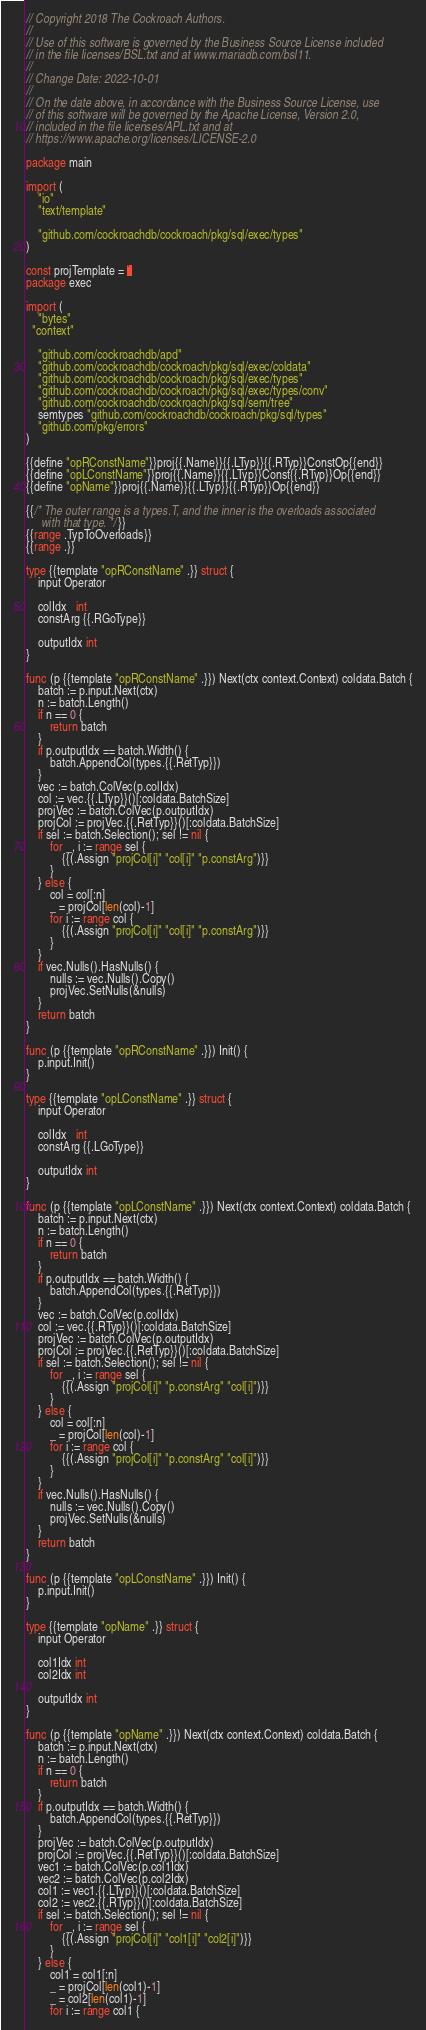<code> <loc_0><loc_0><loc_500><loc_500><_Go_>// Copyright 2018 The Cockroach Authors.
//
// Use of this software is governed by the Business Source License included
// in the file licenses/BSL.txt and at www.mariadb.com/bsl11.
//
// Change Date: 2022-10-01
//
// On the date above, in accordance with the Business Source License, use
// of this software will be governed by the Apache License, Version 2.0,
// included in the file licenses/APL.txt and at
// https://www.apache.org/licenses/LICENSE-2.0

package main

import (
	"io"
	"text/template"

	"github.com/cockroachdb/cockroach/pkg/sql/exec/types"
)

const projTemplate = `
package exec

import (
	"bytes"
  "context"

	"github.com/cockroachdb/apd"
	"github.com/cockroachdb/cockroach/pkg/sql/exec/coldata"
	"github.com/cockroachdb/cockroach/pkg/sql/exec/types"
	"github.com/cockroachdb/cockroach/pkg/sql/exec/types/conv"
	"github.com/cockroachdb/cockroach/pkg/sql/sem/tree"
	semtypes "github.com/cockroachdb/cockroach/pkg/sql/types"
	"github.com/pkg/errors"
)

{{define "opRConstName"}}proj{{.Name}}{{.LTyp}}{{.RTyp}}ConstOp{{end}}
{{define "opLConstName"}}proj{{.Name}}{{.LTyp}}Const{{.RTyp}}Op{{end}}
{{define "opName"}}proj{{.Name}}{{.LTyp}}{{.RTyp}}Op{{end}}

{{/* The outer range is a types.T, and the inner is the overloads associated
     with that type. */}}
{{range .TypToOverloads}}
{{range .}}

type {{template "opRConstName" .}} struct {
	input Operator

	colIdx   int
	constArg {{.RGoType}}

	outputIdx int
}

func (p {{template "opRConstName" .}}) Next(ctx context.Context) coldata.Batch {
	batch := p.input.Next(ctx)
	n := batch.Length()
	if n == 0 {
		return batch
	}
	if p.outputIdx == batch.Width() {
		batch.AppendCol(types.{{.RetTyp}})
	}
	vec := batch.ColVec(p.colIdx)
	col := vec.{{.LTyp}}()[:coldata.BatchSize]
	projVec := batch.ColVec(p.outputIdx)
	projCol := projVec.{{.RetTyp}}()[:coldata.BatchSize]
	if sel := batch.Selection(); sel != nil {
		for _, i := range sel {
			{{(.Assign "projCol[i]" "col[i]" "p.constArg")}}
		}
	} else {
		col = col[:n]
		_ = projCol[len(col)-1]
		for i := range col {
			{{(.Assign "projCol[i]" "col[i]" "p.constArg")}}
		}
	}
	if vec.Nulls().HasNulls() {
		nulls := vec.Nulls().Copy()
		projVec.SetNulls(&nulls)
	}
	return batch
}

func (p {{template "opRConstName" .}}) Init() {
	p.input.Init()
}

type {{template "opLConstName" .}} struct {
	input Operator

	colIdx   int
	constArg {{.LGoType}}

	outputIdx int
}

func (p {{template "opLConstName" .}}) Next(ctx context.Context) coldata.Batch {
	batch := p.input.Next(ctx)
	n := batch.Length()
	if n == 0 {
		return batch
	}
	if p.outputIdx == batch.Width() {
		batch.AppendCol(types.{{.RetTyp}})
	}
	vec := batch.ColVec(p.colIdx)
	col := vec.{{.RTyp}}()[:coldata.BatchSize]
	projVec := batch.ColVec(p.outputIdx)
	projCol := projVec.{{.RetTyp}}()[:coldata.BatchSize]
	if sel := batch.Selection(); sel != nil {
		for _, i := range sel {
			{{(.Assign "projCol[i]" "p.constArg" "col[i]")}}
		}
	} else {
		col = col[:n]
		_ = projCol[len(col)-1]
		for i := range col {
			{{(.Assign "projCol[i]" "p.constArg" "col[i]")}}
		}
	}
	if vec.Nulls().HasNulls() {
		nulls := vec.Nulls().Copy()
		projVec.SetNulls(&nulls)
	}
	return batch
}

func (p {{template "opLConstName" .}}) Init() {
	p.input.Init()
}

type {{template "opName" .}} struct {
	input Operator

	col1Idx int
	col2Idx int

	outputIdx int
}

func (p {{template "opName" .}}) Next(ctx context.Context) coldata.Batch {
	batch := p.input.Next(ctx)
	n := batch.Length()
	if n == 0 {
		return batch
	}
	if p.outputIdx == batch.Width() {
		batch.AppendCol(types.{{.RetTyp}})
	}
	projVec := batch.ColVec(p.outputIdx)
	projCol := projVec.{{.RetTyp}}()[:coldata.BatchSize]
	vec1 := batch.ColVec(p.col1Idx)
	vec2 := batch.ColVec(p.col2Idx)
	col1 := vec1.{{.LTyp}}()[:coldata.BatchSize]
	col2 := vec2.{{.RTyp}}()[:coldata.BatchSize]
	if sel := batch.Selection(); sel != nil {
		for _, i := range sel {
			{{(.Assign "projCol[i]" "col1[i]" "col2[i]")}}
		}
	} else {
		col1 = col1[:n]
		_ = projCol[len(col1)-1]
		_ = col2[len(col1)-1]
		for i := range col1 {</code> 